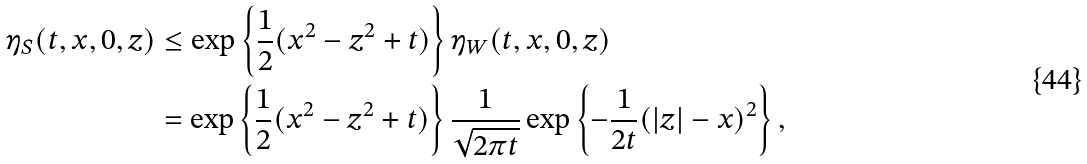<formula> <loc_0><loc_0><loc_500><loc_500>\eta _ { S } ( t , x , 0 , z ) & \leq \exp \left \{ \frac { 1 } { 2 } ( x ^ { 2 } - z ^ { 2 } + t ) \right \} \eta _ { W } ( t , x , 0 , z ) \\ & = \exp \left \{ \frac { 1 } { 2 } ( x ^ { 2 } - z ^ { 2 } + t ) \right \} \frac { 1 } { \sqrt { 2 \pi t } } \exp \left \{ - \frac { 1 } { 2 t } ( | z | - x ) ^ { 2 } \right \} ,</formula> 